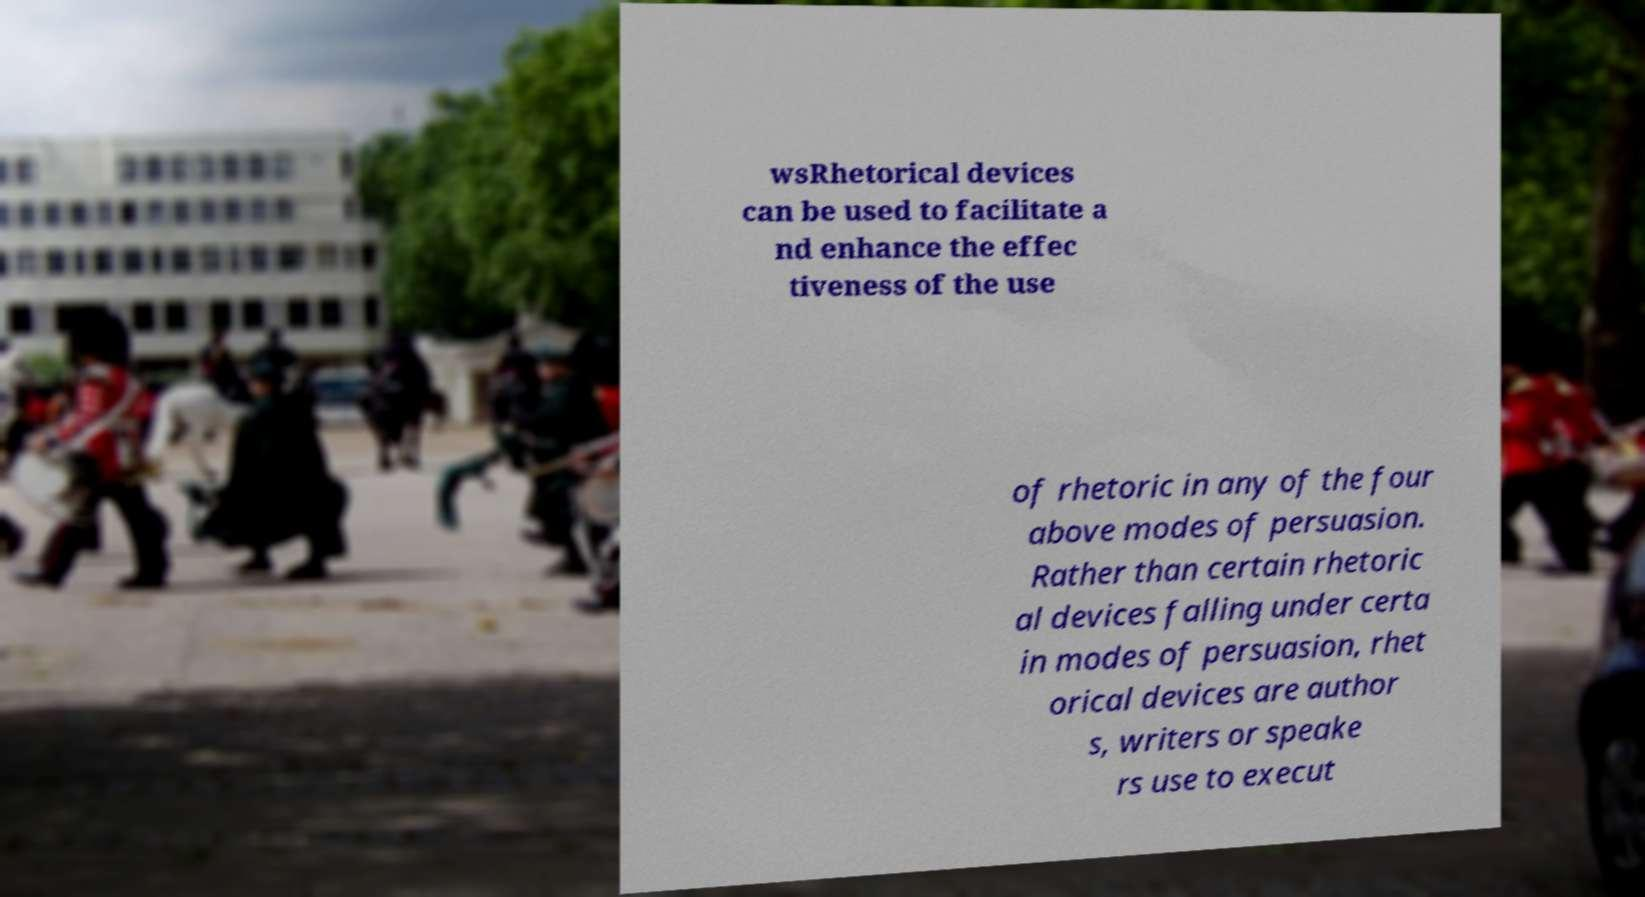I need the written content from this picture converted into text. Can you do that? wsRhetorical devices can be used to facilitate a nd enhance the effec tiveness of the use of rhetoric in any of the four above modes of persuasion. Rather than certain rhetoric al devices falling under certa in modes of persuasion, rhet orical devices are author s, writers or speake rs use to execut 